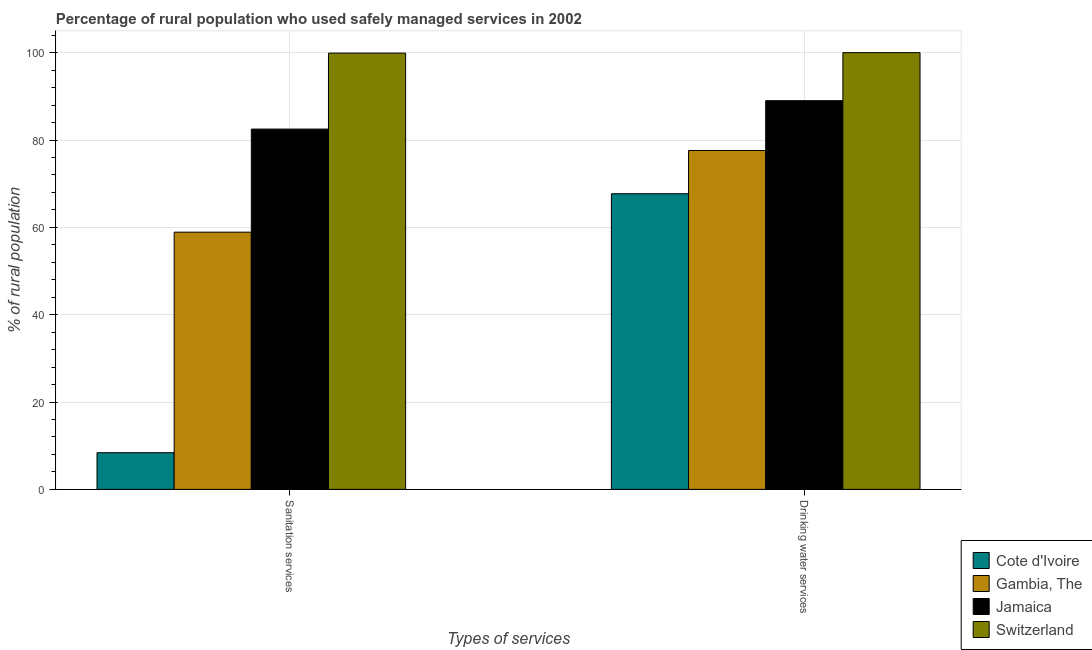How many different coloured bars are there?
Your response must be concise. 4. How many groups of bars are there?
Give a very brief answer. 2. Are the number of bars per tick equal to the number of legend labels?
Provide a short and direct response. Yes. What is the label of the 1st group of bars from the left?
Offer a very short reply. Sanitation services. What is the percentage of rural population who used sanitation services in Switzerland?
Your answer should be compact. 99.9. Across all countries, what is the minimum percentage of rural population who used drinking water services?
Provide a short and direct response. 67.7. In which country was the percentage of rural population who used sanitation services maximum?
Make the answer very short. Switzerland. In which country was the percentage of rural population who used drinking water services minimum?
Give a very brief answer. Cote d'Ivoire. What is the total percentage of rural population who used drinking water services in the graph?
Make the answer very short. 334.3. What is the difference between the percentage of rural population who used sanitation services in Cote d'Ivoire and that in Jamaica?
Offer a very short reply. -74.1. What is the difference between the percentage of rural population who used sanitation services in Jamaica and the percentage of rural population who used drinking water services in Gambia, The?
Provide a succinct answer. 4.9. What is the average percentage of rural population who used sanitation services per country?
Your response must be concise. 62.43. What is the difference between the percentage of rural population who used drinking water services and percentage of rural population who used sanitation services in Cote d'Ivoire?
Your answer should be compact. 59.3. What is the ratio of the percentage of rural population who used sanitation services in Jamaica to that in Gambia, The?
Provide a succinct answer. 1.4. What does the 1st bar from the left in Drinking water services represents?
Your response must be concise. Cote d'Ivoire. What does the 1st bar from the right in Drinking water services represents?
Ensure brevity in your answer.  Switzerland. How many bars are there?
Ensure brevity in your answer.  8. How many countries are there in the graph?
Ensure brevity in your answer.  4. Does the graph contain any zero values?
Offer a terse response. No. Does the graph contain grids?
Offer a terse response. Yes. How many legend labels are there?
Keep it short and to the point. 4. How are the legend labels stacked?
Ensure brevity in your answer.  Vertical. What is the title of the graph?
Keep it short and to the point. Percentage of rural population who used safely managed services in 2002. Does "American Samoa" appear as one of the legend labels in the graph?
Ensure brevity in your answer.  No. What is the label or title of the X-axis?
Offer a very short reply. Types of services. What is the label or title of the Y-axis?
Your answer should be very brief. % of rural population. What is the % of rural population in Gambia, The in Sanitation services?
Your response must be concise. 58.9. What is the % of rural population in Jamaica in Sanitation services?
Keep it short and to the point. 82.5. What is the % of rural population of Switzerland in Sanitation services?
Offer a terse response. 99.9. What is the % of rural population in Cote d'Ivoire in Drinking water services?
Provide a succinct answer. 67.7. What is the % of rural population of Gambia, The in Drinking water services?
Provide a succinct answer. 77.6. What is the % of rural population in Jamaica in Drinking water services?
Offer a very short reply. 89. Across all Types of services, what is the maximum % of rural population in Cote d'Ivoire?
Give a very brief answer. 67.7. Across all Types of services, what is the maximum % of rural population of Gambia, The?
Give a very brief answer. 77.6. Across all Types of services, what is the maximum % of rural population of Jamaica?
Make the answer very short. 89. Across all Types of services, what is the maximum % of rural population in Switzerland?
Provide a succinct answer. 100. Across all Types of services, what is the minimum % of rural population of Gambia, The?
Give a very brief answer. 58.9. Across all Types of services, what is the minimum % of rural population in Jamaica?
Ensure brevity in your answer.  82.5. Across all Types of services, what is the minimum % of rural population in Switzerland?
Provide a succinct answer. 99.9. What is the total % of rural population in Cote d'Ivoire in the graph?
Ensure brevity in your answer.  76.1. What is the total % of rural population of Gambia, The in the graph?
Make the answer very short. 136.5. What is the total % of rural population in Jamaica in the graph?
Ensure brevity in your answer.  171.5. What is the total % of rural population of Switzerland in the graph?
Your answer should be very brief. 199.9. What is the difference between the % of rural population in Cote d'Ivoire in Sanitation services and that in Drinking water services?
Give a very brief answer. -59.3. What is the difference between the % of rural population in Gambia, The in Sanitation services and that in Drinking water services?
Provide a succinct answer. -18.7. What is the difference between the % of rural population in Jamaica in Sanitation services and that in Drinking water services?
Provide a short and direct response. -6.5. What is the difference between the % of rural population in Switzerland in Sanitation services and that in Drinking water services?
Provide a short and direct response. -0.1. What is the difference between the % of rural population of Cote d'Ivoire in Sanitation services and the % of rural population of Gambia, The in Drinking water services?
Your answer should be compact. -69.2. What is the difference between the % of rural population of Cote d'Ivoire in Sanitation services and the % of rural population of Jamaica in Drinking water services?
Keep it short and to the point. -80.6. What is the difference between the % of rural population of Cote d'Ivoire in Sanitation services and the % of rural population of Switzerland in Drinking water services?
Give a very brief answer. -91.6. What is the difference between the % of rural population of Gambia, The in Sanitation services and the % of rural population of Jamaica in Drinking water services?
Your response must be concise. -30.1. What is the difference between the % of rural population in Gambia, The in Sanitation services and the % of rural population in Switzerland in Drinking water services?
Offer a terse response. -41.1. What is the difference between the % of rural population in Jamaica in Sanitation services and the % of rural population in Switzerland in Drinking water services?
Offer a very short reply. -17.5. What is the average % of rural population of Cote d'Ivoire per Types of services?
Your response must be concise. 38.05. What is the average % of rural population of Gambia, The per Types of services?
Provide a short and direct response. 68.25. What is the average % of rural population of Jamaica per Types of services?
Provide a succinct answer. 85.75. What is the average % of rural population in Switzerland per Types of services?
Offer a terse response. 99.95. What is the difference between the % of rural population of Cote d'Ivoire and % of rural population of Gambia, The in Sanitation services?
Ensure brevity in your answer.  -50.5. What is the difference between the % of rural population in Cote d'Ivoire and % of rural population in Jamaica in Sanitation services?
Keep it short and to the point. -74.1. What is the difference between the % of rural population of Cote d'Ivoire and % of rural population of Switzerland in Sanitation services?
Offer a very short reply. -91.5. What is the difference between the % of rural population in Gambia, The and % of rural population in Jamaica in Sanitation services?
Offer a very short reply. -23.6. What is the difference between the % of rural population in Gambia, The and % of rural population in Switzerland in Sanitation services?
Your answer should be compact. -41. What is the difference between the % of rural population in Jamaica and % of rural population in Switzerland in Sanitation services?
Ensure brevity in your answer.  -17.4. What is the difference between the % of rural population in Cote d'Ivoire and % of rural population in Gambia, The in Drinking water services?
Your response must be concise. -9.9. What is the difference between the % of rural population of Cote d'Ivoire and % of rural population of Jamaica in Drinking water services?
Offer a terse response. -21.3. What is the difference between the % of rural population in Cote d'Ivoire and % of rural population in Switzerland in Drinking water services?
Ensure brevity in your answer.  -32.3. What is the difference between the % of rural population in Gambia, The and % of rural population in Jamaica in Drinking water services?
Provide a succinct answer. -11.4. What is the difference between the % of rural population of Gambia, The and % of rural population of Switzerland in Drinking water services?
Your answer should be very brief. -22.4. What is the ratio of the % of rural population of Cote d'Ivoire in Sanitation services to that in Drinking water services?
Give a very brief answer. 0.12. What is the ratio of the % of rural population of Gambia, The in Sanitation services to that in Drinking water services?
Your answer should be very brief. 0.76. What is the ratio of the % of rural population in Jamaica in Sanitation services to that in Drinking water services?
Keep it short and to the point. 0.93. What is the difference between the highest and the second highest % of rural population in Cote d'Ivoire?
Give a very brief answer. 59.3. What is the difference between the highest and the second highest % of rural population of Gambia, The?
Your answer should be very brief. 18.7. What is the difference between the highest and the second highest % of rural population in Switzerland?
Your answer should be compact. 0.1. What is the difference between the highest and the lowest % of rural population in Cote d'Ivoire?
Your response must be concise. 59.3. What is the difference between the highest and the lowest % of rural population of Jamaica?
Your response must be concise. 6.5. What is the difference between the highest and the lowest % of rural population of Switzerland?
Your response must be concise. 0.1. 